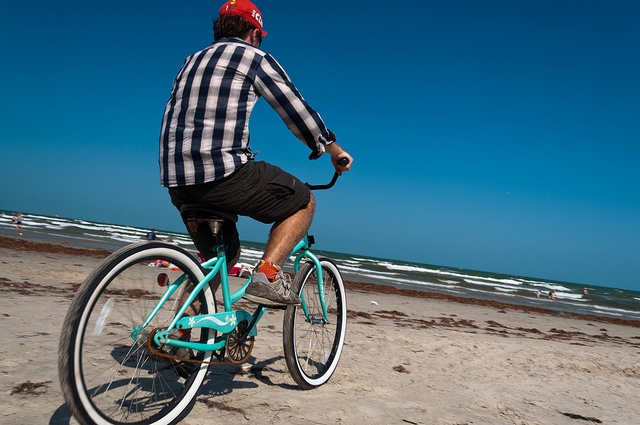Describe the objects in this image and their specific colors. I can see people in darkblue, black, darkgray, gray, and lightgray tones, bicycle in darkblue, black, darkgray, gray, and lightgray tones, people in darkblue, gray, darkgray, and black tones, people in darkblue, black, navy, blue, and gray tones, and people in darkblue, brown, gray, and black tones in this image. 